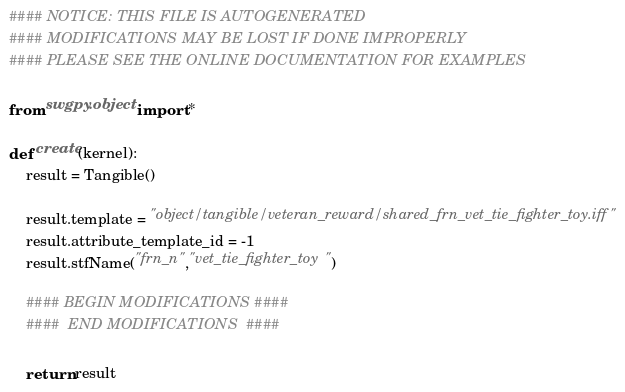<code> <loc_0><loc_0><loc_500><loc_500><_Python_>#### NOTICE: THIS FILE IS AUTOGENERATED
#### MODIFICATIONS MAY BE LOST IF DONE IMPROPERLY
#### PLEASE SEE THE ONLINE DOCUMENTATION FOR EXAMPLES

from swgpy.object import *	

def create(kernel):
	result = Tangible()

	result.template = "object/tangible/veteran_reward/shared_frn_vet_tie_fighter_toy.iff"
	result.attribute_template_id = -1
	result.stfName("frn_n","vet_tie_fighter_toy")		
	
	#### BEGIN MODIFICATIONS ####
	####  END MODIFICATIONS  ####
	
	return result</code> 